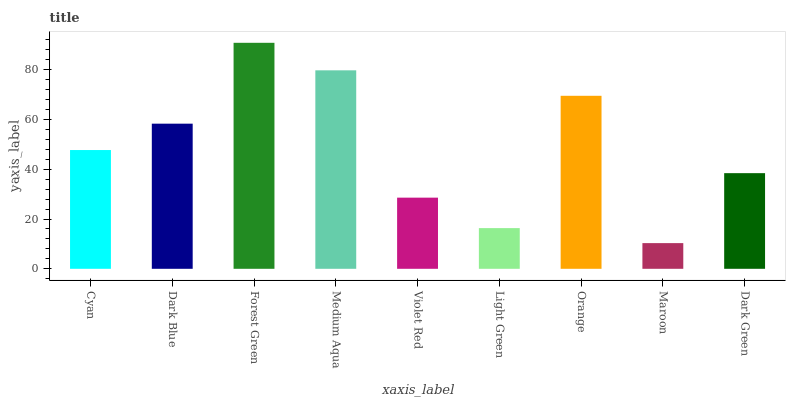Is Maroon the minimum?
Answer yes or no. Yes. Is Forest Green the maximum?
Answer yes or no. Yes. Is Dark Blue the minimum?
Answer yes or no. No. Is Dark Blue the maximum?
Answer yes or no. No. Is Dark Blue greater than Cyan?
Answer yes or no. Yes. Is Cyan less than Dark Blue?
Answer yes or no. Yes. Is Cyan greater than Dark Blue?
Answer yes or no. No. Is Dark Blue less than Cyan?
Answer yes or no. No. Is Cyan the high median?
Answer yes or no. Yes. Is Cyan the low median?
Answer yes or no. Yes. Is Orange the high median?
Answer yes or no. No. Is Light Green the low median?
Answer yes or no. No. 